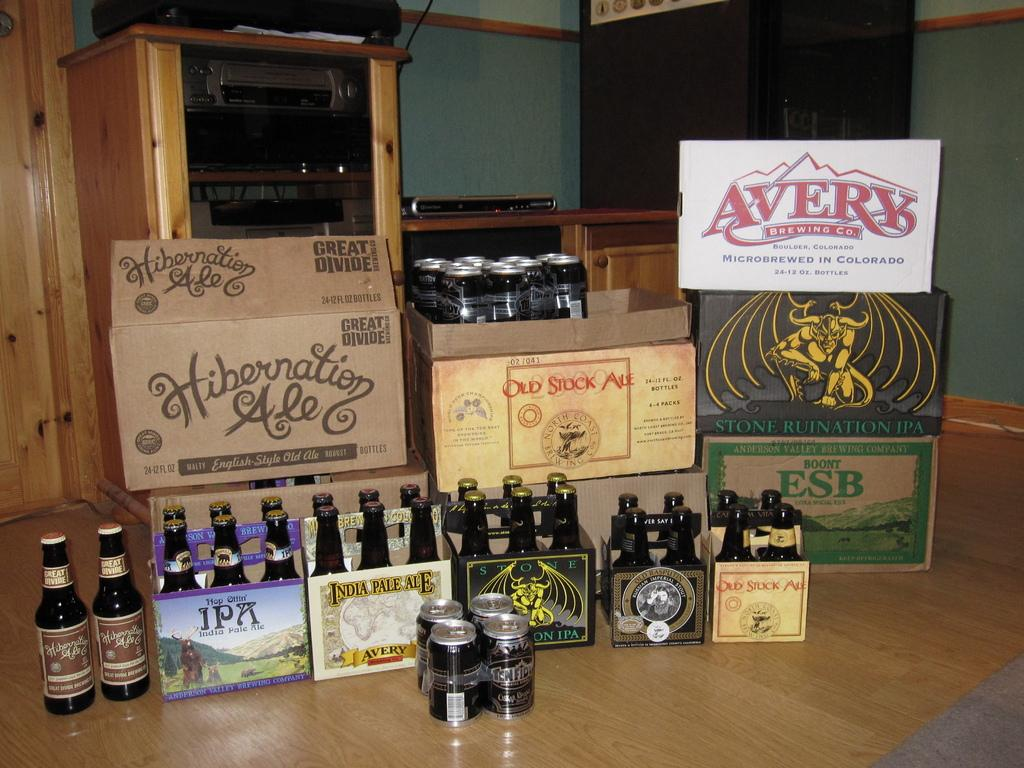<image>
Provide a brief description of the given image. the word averv that is on a sign indoors 